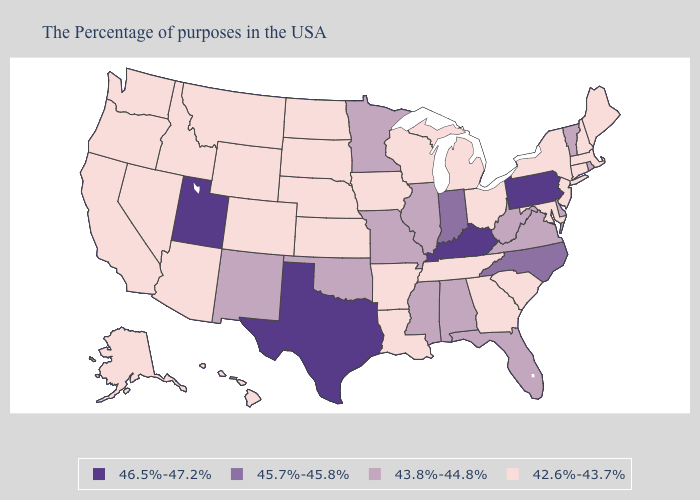Does Tennessee have the same value as Georgia?
Be succinct. Yes. Does Minnesota have a higher value than Iowa?
Concise answer only. Yes. Which states have the lowest value in the Northeast?
Short answer required. Maine, Massachusetts, New Hampshire, Connecticut, New York, New Jersey. Name the states that have a value in the range 45.7%-45.8%?
Give a very brief answer. North Carolina, Indiana. Name the states that have a value in the range 42.6%-43.7%?
Give a very brief answer. Maine, Massachusetts, New Hampshire, Connecticut, New York, New Jersey, Maryland, South Carolina, Ohio, Georgia, Michigan, Tennessee, Wisconsin, Louisiana, Arkansas, Iowa, Kansas, Nebraska, South Dakota, North Dakota, Wyoming, Colorado, Montana, Arizona, Idaho, Nevada, California, Washington, Oregon, Alaska, Hawaii. What is the value of Kentucky?
Give a very brief answer. 46.5%-47.2%. What is the value of Virginia?
Concise answer only. 43.8%-44.8%. Does Texas have the highest value in the USA?
Answer briefly. Yes. Does New Mexico have the lowest value in the West?
Quick response, please. No. Name the states that have a value in the range 43.8%-44.8%?
Give a very brief answer. Rhode Island, Vermont, Delaware, Virginia, West Virginia, Florida, Alabama, Illinois, Mississippi, Missouri, Minnesota, Oklahoma, New Mexico. What is the value of Alabama?
Answer briefly. 43.8%-44.8%. Does Arizona have a higher value than New Jersey?
Be succinct. No. Does Utah have the highest value in the USA?
Quick response, please. Yes. What is the highest value in the USA?
Be succinct. 46.5%-47.2%. Name the states that have a value in the range 42.6%-43.7%?
Give a very brief answer. Maine, Massachusetts, New Hampshire, Connecticut, New York, New Jersey, Maryland, South Carolina, Ohio, Georgia, Michigan, Tennessee, Wisconsin, Louisiana, Arkansas, Iowa, Kansas, Nebraska, South Dakota, North Dakota, Wyoming, Colorado, Montana, Arizona, Idaho, Nevada, California, Washington, Oregon, Alaska, Hawaii. 